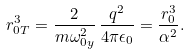Convert formula to latex. <formula><loc_0><loc_0><loc_500><loc_500>r _ { 0 T } ^ { 3 } = \frac { 2 } { m \omega _ { 0 y } ^ { 2 } } \, \frac { q ^ { 2 } } { 4 \pi \epsilon _ { 0 } } = \frac { r _ { 0 } ^ { 3 } } { \alpha ^ { 2 } } .</formula> 